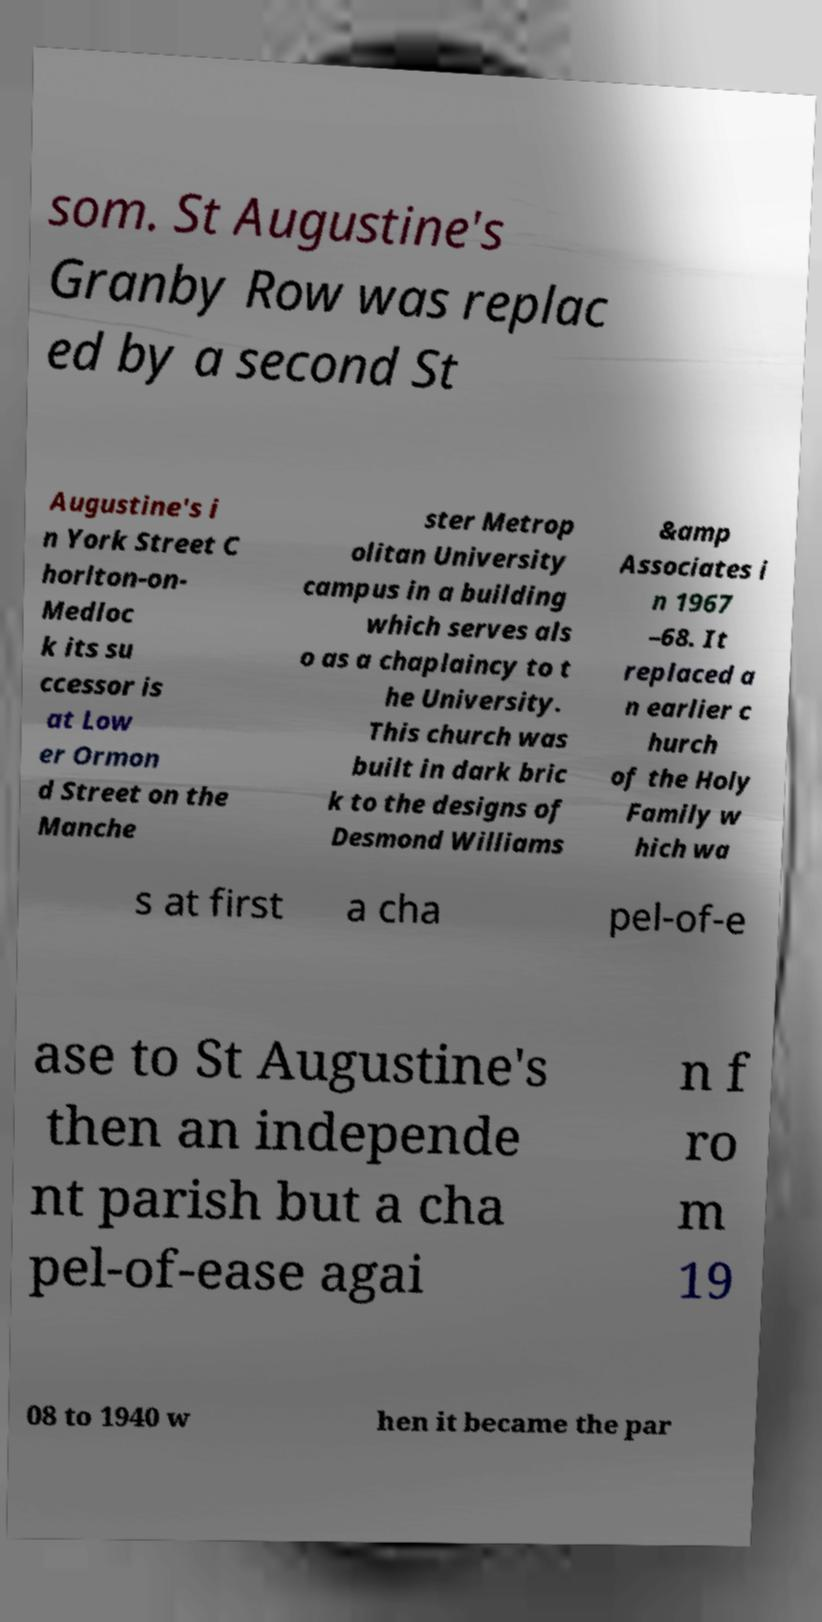Can you read and provide the text displayed in the image?This photo seems to have some interesting text. Can you extract and type it out for me? som. St Augustine's Granby Row was replac ed by a second St Augustine's i n York Street C horlton-on- Medloc k its su ccessor is at Low er Ormon d Street on the Manche ster Metrop olitan University campus in a building which serves als o as a chaplaincy to t he University. This church was built in dark bric k to the designs of Desmond Williams &amp Associates i n 1967 –68. It replaced a n earlier c hurch of the Holy Family w hich wa s at first a cha pel-of-e ase to St Augustine's then an independe nt parish but a cha pel-of-ease agai n f ro m 19 08 to 1940 w hen it became the par 